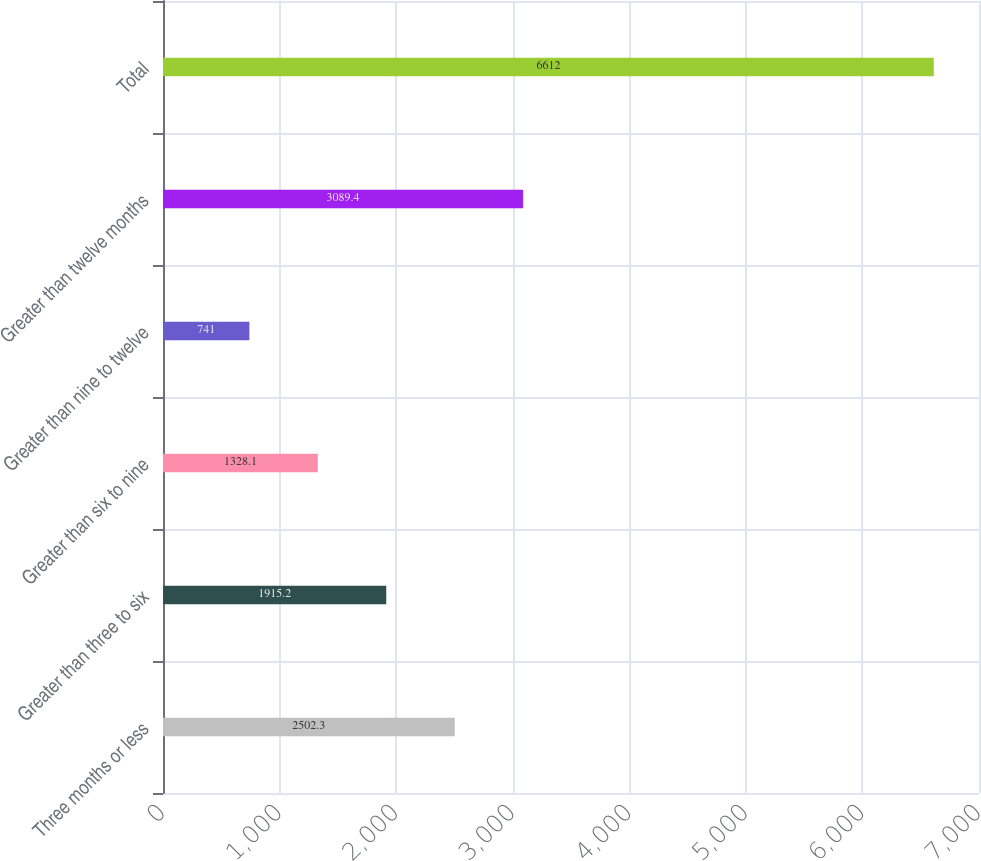<chart> <loc_0><loc_0><loc_500><loc_500><bar_chart><fcel>Three months or less<fcel>Greater than three to six<fcel>Greater than six to nine<fcel>Greater than nine to twelve<fcel>Greater than twelve months<fcel>Total<nl><fcel>2502.3<fcel>1915.2<fcel>1328.1<fcel>741<fcel>3089.4<fcel>6612<nl></chart> 